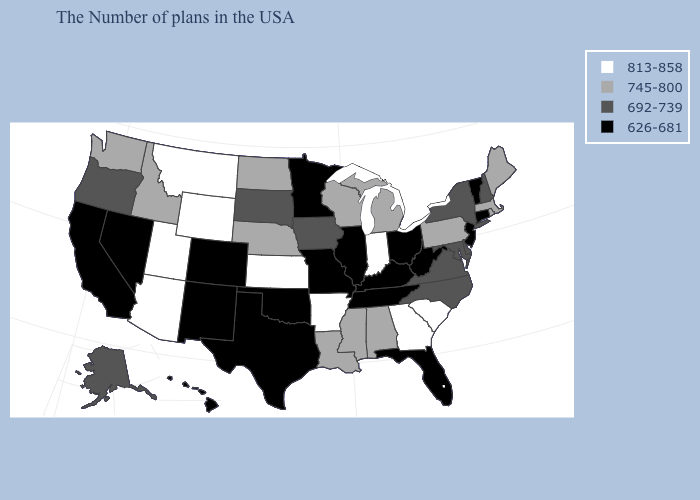What is the value of Nebraska?
Be succinct. 745-800. Which states have the lowest value in the MidWest?
Be succinct. Ohio, Illinois, Missouri, Minnesota. What is the value of Hawaii?
Quick response, please. 626-681. What is the highest value in the MidWest ?
Concise answer only. 813-858. Does the first symbol in the legend represent the smallest category?
Be succinct. No. What is the value of Wisconsin?
Answer briefly. 745-800. Name the states that have a value in the range 813-858?
Concise answer only. South Carolina, Georgia, Indiana, Arkansas, Kansas, Wyoming, Utah, Montana, Arizona. Which states have the highest value in the USA?
Answer briefly. South Carolina, Georgia, Indiana, Arkansas, Kansas, Wyoming, Utah, Montana, Arizona. Does Connecticut have the same value as Florida?
Give a very brief answer. Yes. Does New Jersey have a lower value than Tennessee?
Answer briefly. No. Among the states that border Maryland , does Delaware have the lowest value?
Keep it brief. No. Among the states that border South Dakota , does Montana have the highest value?
Quick response, please. Yes. Does Kansas have the highest value in the USA?
Quick response, please. Yes. Among the states that border Pennsylvania , does New York have the highest value?
Give a very brief answer. Yes. What is the value of Michigan?
Give a very brief answer. 745-800. 